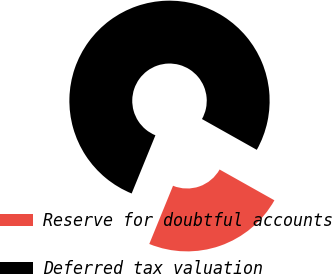Convert chart. <chart><loc_0><loc_0><loc_500><loc_500><pie_chart><fcel>Reserve for doubtful accounts<fcel>Deferred tax valuation<nl><fcel>23.02%<fcel>76.98%<nl></chart> 